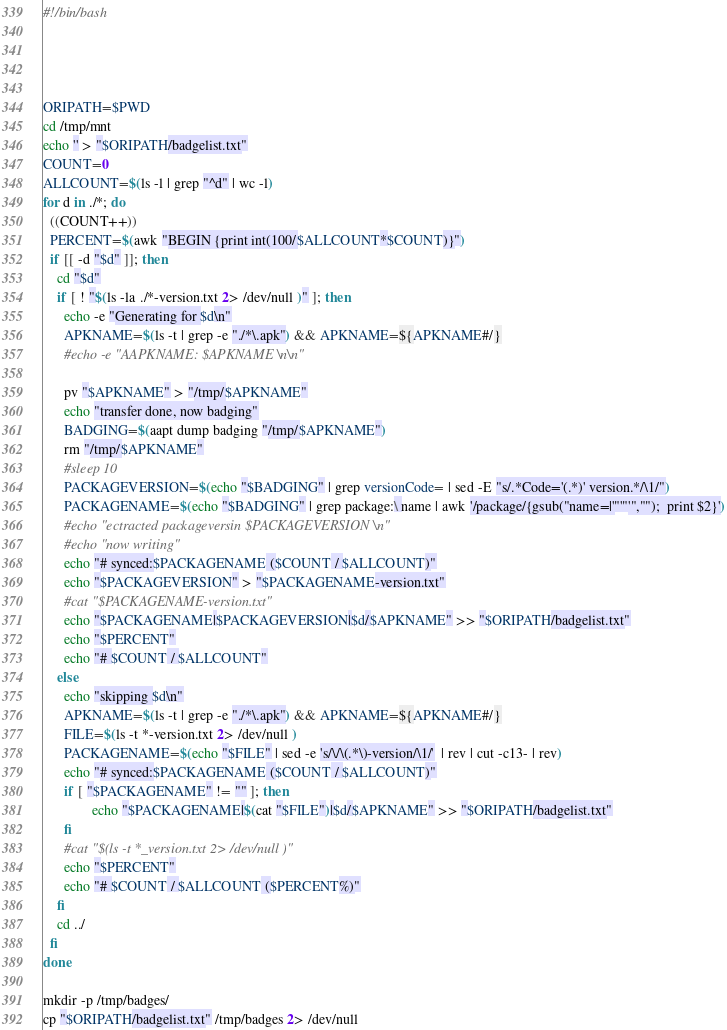Convert code to text. <code><loc_0><loc_0><loc_500><loc_500><_Bash_>#!/bin/bash




ORIPATH=$PWD
cd /tmp/mnt
echo '' > "$ORIPATH/badgelist.txt"
COUNT=0
ALLCOUNT=$(ls -l | grep "^d" | wc -l)
for d in ./*; do
  ((COUNT++))
  PERCENT=$(awk "BEGIN {print int(100/$ALLCOUNT*$COUNT)}")
  if [[ -d "$d" ]]; then
    cd "$d"
    if [ ! "$(ls -la ./*-version.txt 2> /dev/null )" ]; then
      echo -e "Generating for $d\n"
      APKNAME=$(ls -t | grep -e "./*\.apk") && APKNAME=${APKNAME#/}
      #echo -e "AAPKNAME: $APKNAME \n\n"

      pv "$APKNAME" > "/tmp/$APKNAME"
      echo "transfer done, now badging"
      BADGING=$(aapt dump badging "/tmp/$APKNAME")
      rm "/tmp/$APKNAME"
      #sleep 10
      PACKAGEVERSION=$(echo "$BADGING" | grep versionCode= | sed -E "s/.*Code='(.*)' version.*/\1/")
      PACKAGENAME=$(echo "$BADGING" | grep package:\ name | awk '/package/{gsub("name=|'"'"'","");  print $2}')
      #echo "ectracted packageversin $PACKAGEVERSION \n"
      #echo "now writing"
      echo "# synced:$PACKAGENAME ($COUNT / $ALLCOUNT)"
      echo "$PACKAGEVERSION" > "$PACKAGENAME-version.txt"
      #cat "$PACKAGENAME-version.txt"
      echo "$PACKAGENAME|$PACKAGEVERSION|$d/$APKNAME" >> "$ORIPATH/badgelist.txt"
      echo "$PERCENT"
      echo "# $COUNT / $ALLCOUNT"
    else
      echo "skipping $d\n"
      APKNAME=$(ls -t | grep -e "./*\.apk") && APKNAME=${APKNAME#/}
      FILE=$(ls -t *-version.txt 2> /dev/null )
      PACKAGENAME=$(echo "$FILE" | sed -e 's/\/\(.*\)-version/\1/'  | rev | cut -c13- | rev)
      echo "# synced:$PACKAGENAME ($COUNT / $ALLCOUNT)"
      if [ "$PACKAGENAME" != "" ]; then
              echo "$PACKAGENAME|$(cat "$FILE")|$d/$APKNAME" >> "$ORIPATH/badgelist.txt"
      fi
      #cat "$(ls -t *_version.txt 2> /dev/null )"
      echo "$PERCENT"
      echo "# $COUNT / $ALLCOUNT ($PERCENT%)"
    fi
    cd ../
  fi
done

mkdir -p /tmp/badges/
cp "$ORIPATH/badgelist.txt" /tmp/badges 2> /dev/null
</code> 